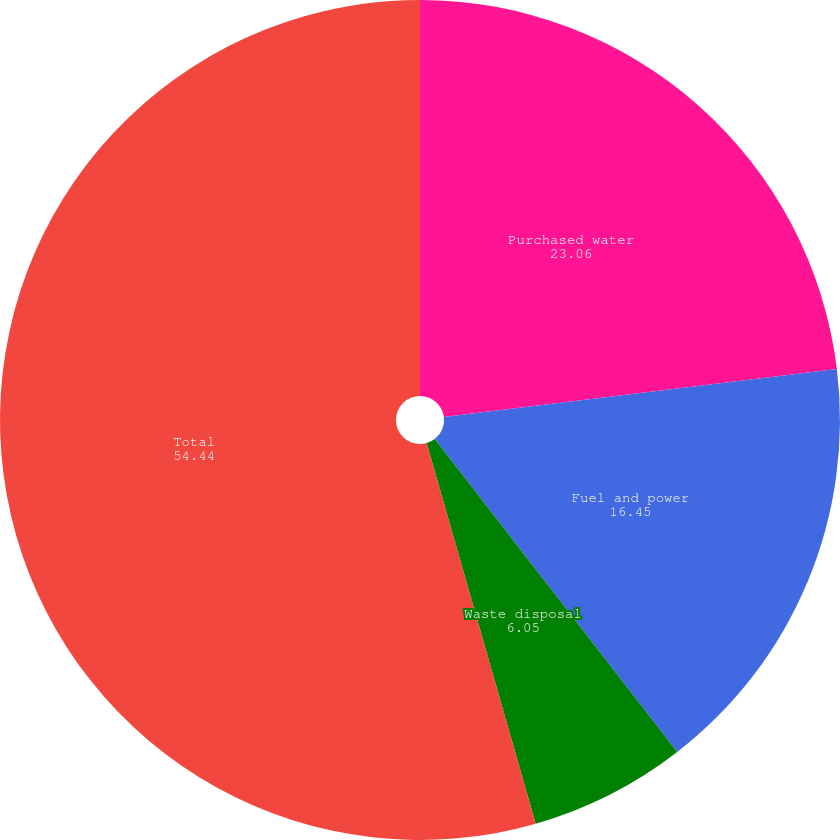Convert chart. <chart><loc_0><loc_0><loc_500><loc_500><pie_chart><fcel>Purchased water<fcel>Fuel and power<fcel>Waste disposal<fcel>Total<nl><fcel>23.06%<fcel>16.45%<fcel>6.05%<fcel>54.44%<nl></chart> 